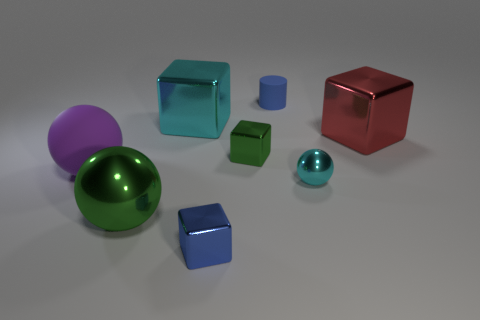What number of other objects are the same size as the blue metallic object?
Your response must be concise. 3. Is the number of blue matte cylinders greater than the number of tiny brown metallic objects?
Give a very brief answer. Yes. What number of objects are both in front of the blue matte object and behind the red block?
Make the answer very short. 1. What is the shape of the rubber thing that is right of the small cube in front of the cyan thing that is to the right of the tiny cylinder?
Give a very brief answer. Cylinder. Are there any other things that are the same shape as the red object?
Make the answer very short. Yes. What number of cylinders are either large purple things or matte things?
Your answer should be compact. 1. There is a shiny object that is behind the large red shiny cube; does it have the same color as the small ball?
Your response must be concise. Yes. What is the material of the cyan thing on the left side of the tiny blue thing that is in front of the cube that is behind the large red shiny thing?
Ensure brevity in your answer.  Metal. Do the green ball and the blue block have the same size?
Your answer should be very brief. No. Does the big metallic sphere have the same color as the metallic object that is on the right side of the small cyan object?
Ensure brevity in your answer.  No. 